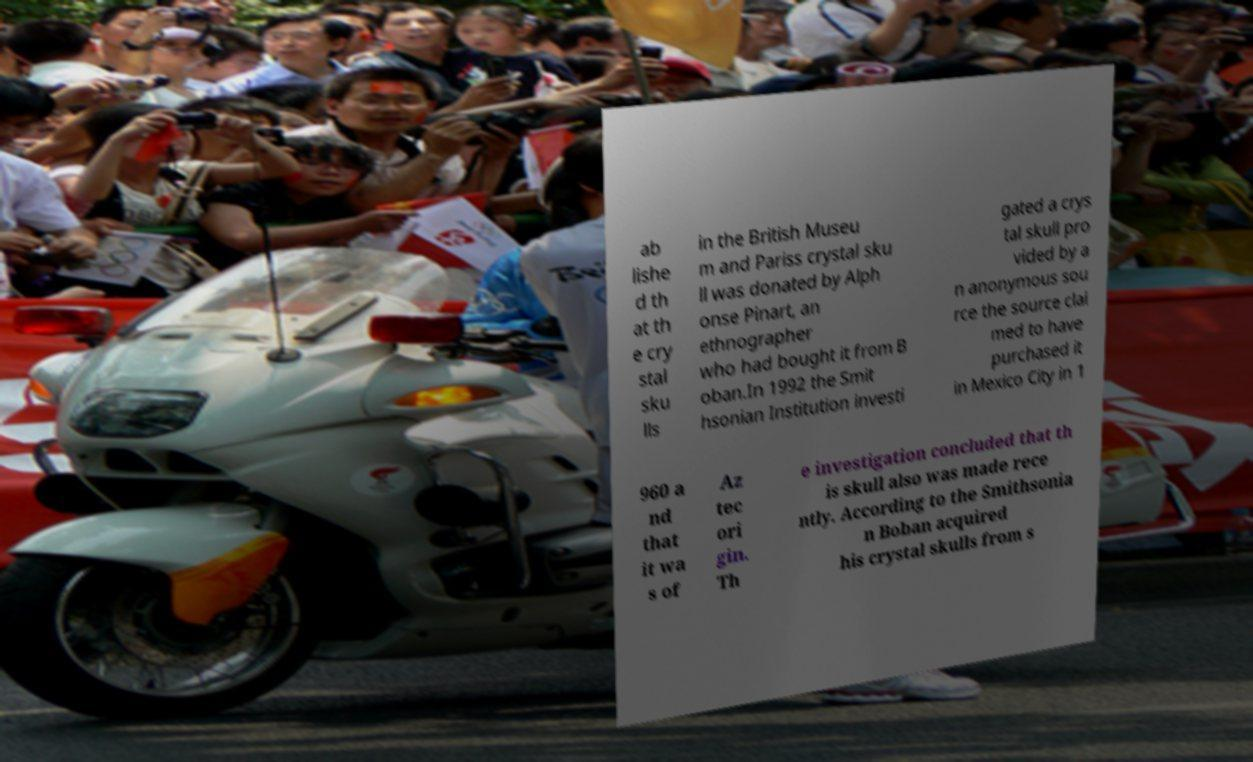Could you assist in decoding the text presented in this image and type it out clearly? ab lishe d th at th e cry stal sku lls in the British Museu m and Pariss crystal sku ll was donated by Alph onse Pinart, an ethnographer who had bought it from B oban.In 1992 the Smit hsonian Institution investi gated a crys tal skull pro vided by a n anonymous sou rce the source clai med to have purchased it in Mexico City in 1 960 a nd that it wa s of Az tec ori gin. Th e investigation concluded that th is skull also was made rece ntly. According to the Smithsonia n Boban acquired his crystal skulls from s 